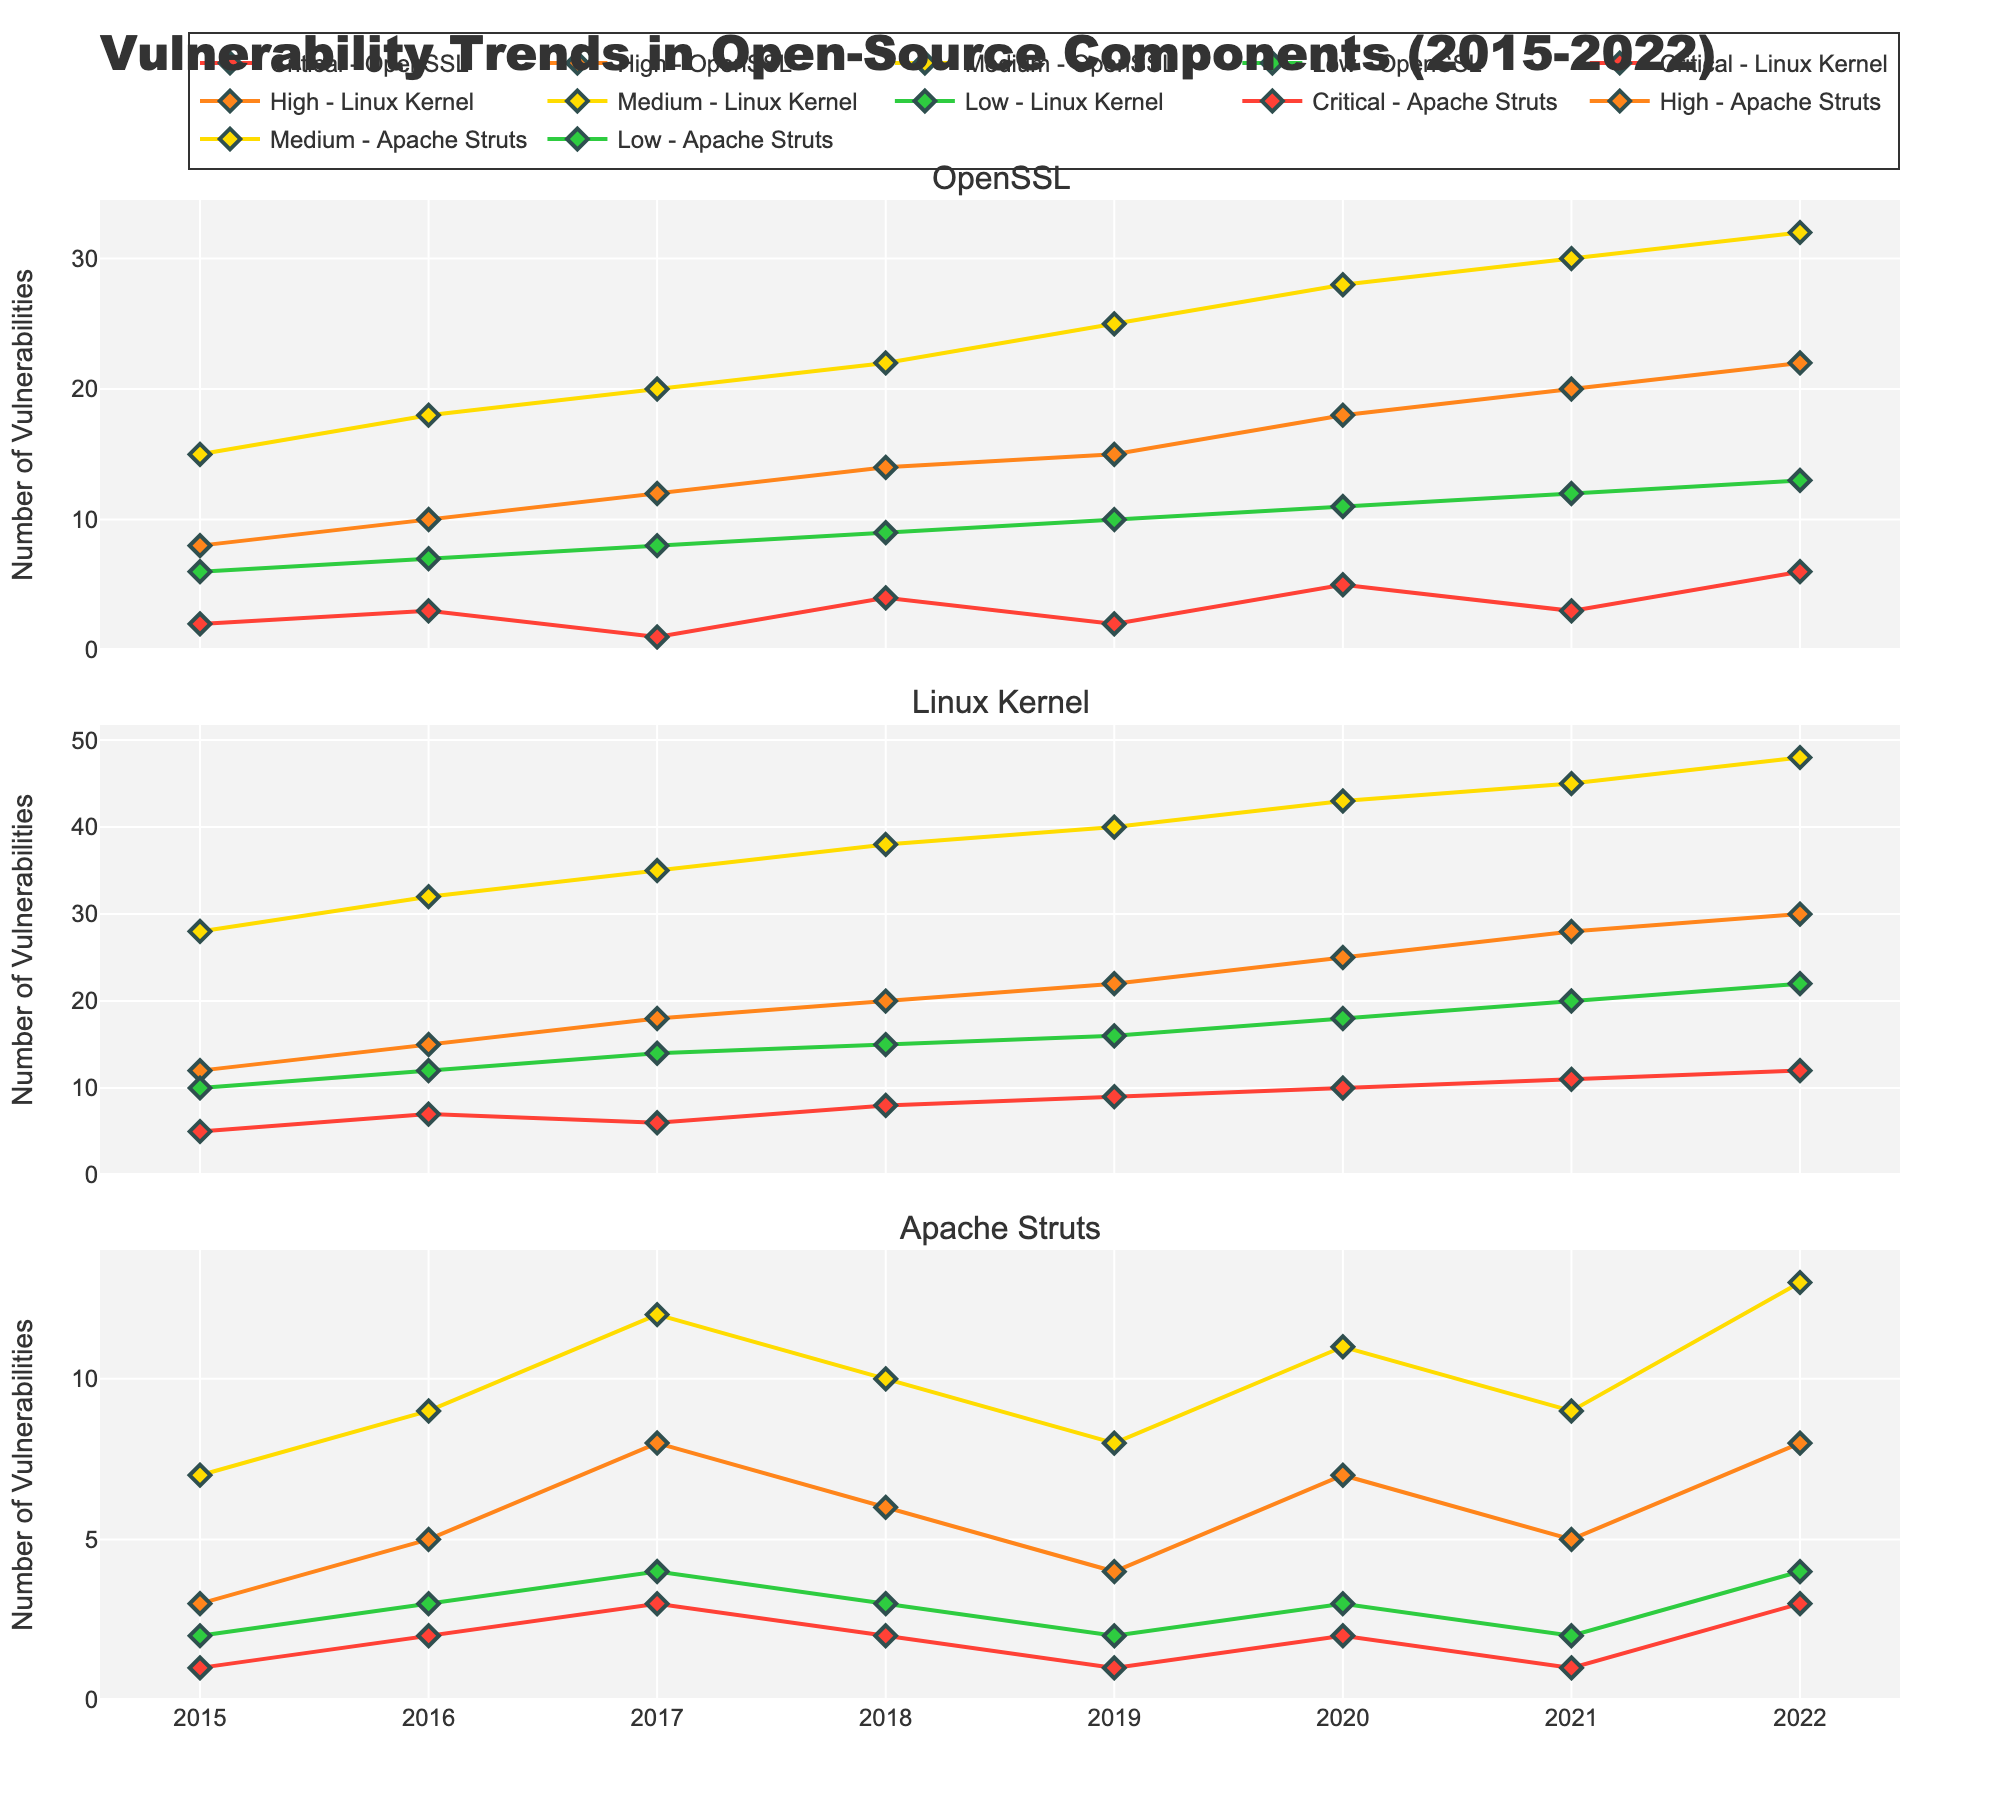What year did Critical vulnerabilities for Apache Struts peak? The peak is identified by finding the highest point of the graph line corresponding to Critical vulnerabilities for Apache Struts. This occurs in years where the line has its highest y-value, which is 3 in both 2017 and 2022. Thus, 2022 is the latest peak year.
Answer: 2022 Which component had the highest number of High vulnerabilities in 2022? To determine this, look at the different lines corresponding to High vulnerabilities for each component in the 2022 section. The Linux Kernel line shows the highest value of 30.
Answer: Linux Kernel Compare the number of Medium vulnerabilities for OpenSSL in 2015 and 2022. Has it increased or decreased? Check the y-values of the Medium-OpenSSL line at the 2015 and 2022 points. In 2015, the value is 15, and in 2022, the value is 32. Thus, it has increased.
Answer: Increased Calculate the average number of Low vulnerabilities for the Linux Kernel from 2015 to 2022. Sum up the values for Low-Linux Kernel from 2015 to 2022 (10, 12, 14, 15, 16, 18, 20, 22), which is 127, and divide by the number of years (8). The average is 127 / 8 = 15.88.
Answer: 15.88 Between 2016 and 2017, which component saw a decrease in Critical vulnerabilities? Compare the y-values of the Critical lines for each component between 2016 and 2017. OpenSSL decreases from 3 to 1, Linux Kernel decreases from 7 to 6, and Apache Struts increases from 2 to 3. Thus, the components with decreases are OpenSSL and Linux Kernel.
Answer: OpenSSL, Linux Kernel How did the number of High vulnerabilities for Apache Struts change from 2021 to 2022? Examine the values of High-Apache Struts from 2021 (5) to 2022 (8). The visual difference shows an increase.
Answer: Increased What is the total number of Critical vulnerabilities reported in 2020 for all components? Sum the Critical vulnerabilities for all components in 2020: 5 (OpenSSL) + 10 (Linux Kernel) + 2 (Apache Struts) = 17.
Answer: 17 Which severity level shows the greatest increase in vulnerabilities for the Linux Kernel between 2015 and 2022? Examine the changes in y-values for all severity levels of Linux Kernel from 2015 to 2022. Critical: 5 to 12 (increase of 7), High: 12 to 30 (increase of 18), Medium: 28 to 48 (increase of 20), Low: 10 to 22 (increase of 12). The greatest increase is in Medium vulnerabilities (20).
Answer: Medium What is the trend for Low vulnerabilities in Apache Struts from 2015 to 2022? By following the line for Low-Apache Struts, see the general direction: it starts at 2, fluctuates slightly and ends at 4 in 2022 indicating a slight upward trend.
Answer: Slight upward Compare the highest peak of Medium vulnerabilities for OpenSSL to the highest peak of High vulnerabilities for OpenSSL. When did they occur and what were their values? Identify the highest points on the lines for Medium-OpenSSL and High-OpenSSL. Medium-OpenSSL peaks at 32 in 2022. High-OpenSSL peaks at 22 also in 2022. Thus, peaks are both in 2022 with values 32 and 22 respectively.
Answer: 2022, Medium: 32, High: 22 